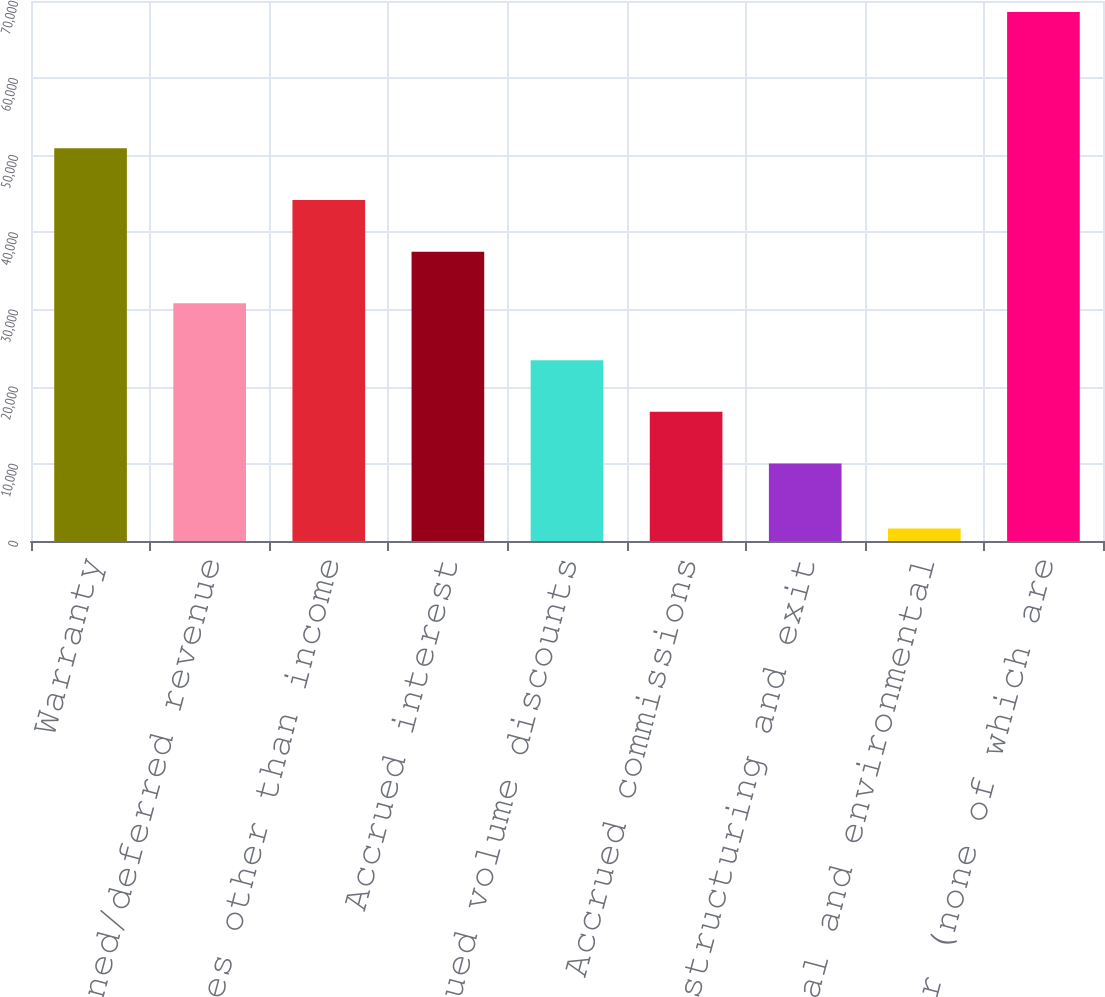Convert chart to OTSL. <chart><loc_0><loc_0><loc_500><loc_500><bar_chart><fcel>Warranty<fcel>Unearned/deferred revenue<fcel>Taxes other than income<fcel>Accrued interest<fcel>Accrued volume discounts<fcel>Accrued commissions<fcel>Restructuring and exit<fcel>Legal and environmental<fcel>Other (none of which are<nl><fcel>50899.3<fcel>30817<fcel>44205.2<fcel>37511.1<fcel>23434.2<fcel>16740.1<fcel>10046<fcel>1623<fcel>68564<nl></chart> 